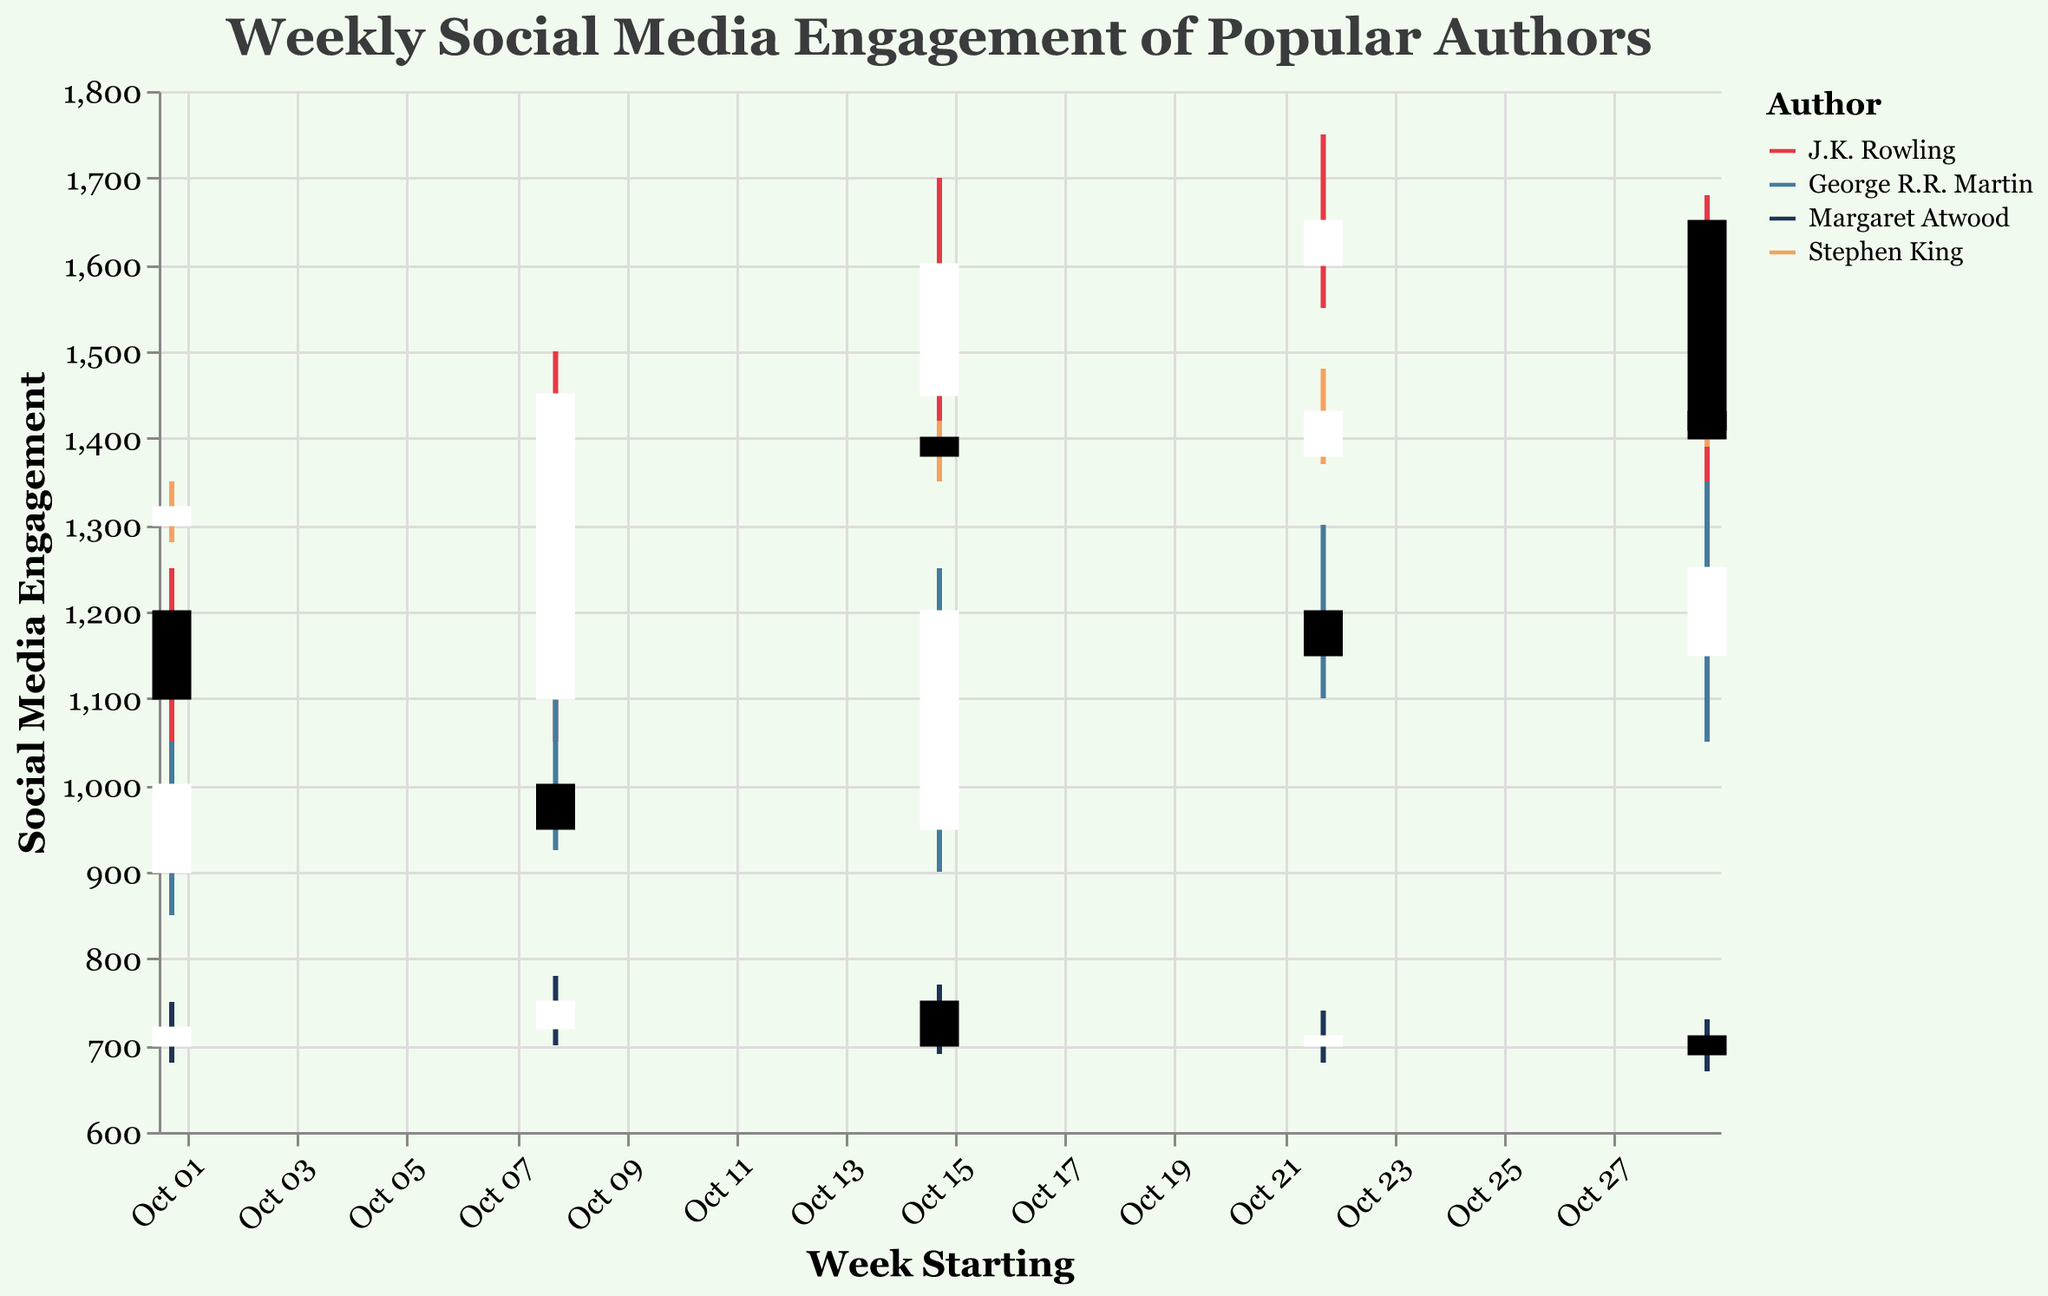What is the title of the figure? The title of the figure is displayed at the top and it reads "Weekly Social Media Engagement of Popular Authors".
Answer: Weekly Social Media Engagement of Popular Authors Which author had the highest "High Interest" during the week starting Oct 29? J.K. Rowling had the highest "High Interest" during the week starting Oct 29 with a high of 1680, as seen at the top of the candlestick for that week.
Answer: J.K. Rowling What is the time range displayed on the x-axis? The x-axis shows the weeks in October 2023, from "Oct 01" to "Oct 29".
Answer: October 2023 Which author saw an increase in "Close Interest" every week except the last week? Stephen King saw an increase in "Close Interest" from week to week except for the last week (Oct 29) where it decreased slightly. This can be seen by observing the candlesticks from Oct 01 to Oct 29.
Answer: Stephen King What is the color of the candlestick bars for J.K. Rowling? J.K. Rowling’s candlestick bars are colored red.
Answer: Red Between George R.R. Martin and Margaret Atwood, who had a higher "Low Interest" in the week starting Oct 08? George R.R. Martin had a higher "Low Interest" of 925, compared to Margaret Atwood's 700, as indicated by the bottom of the respective candlesticks.
Answer: George R.R. Martin What was the difference between the "Open Interest" and "Close Interest" for J.K. Rowling on Oct 15? The "Open Interest" was 1450 and the "Close Interest" was 1600, so the difference is 1600 - 1450 = 150.
Answer: 150 Which author had the greatest weekly decrease in "Close Interest"? J.K. Rowling had the greatest weekly decrease in "Close Interest" between Oct 22 and Oct 29, from 1650 to 1400, a decrease of 250. This can be determined by looking at the difference in height between the top of the Oct 22 bar and the bottom of the Oct 29 bar.
Answer: J.K. Rowling 